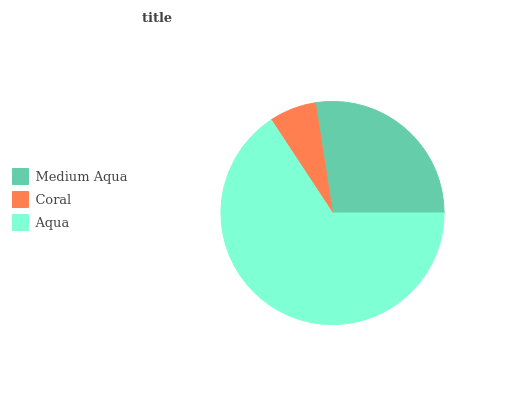Is Coral the minimum?
Answer yes or no. Yes. Is Aqua the maximum?
Answer yes or no. Yes. Is Aqua the minimum?
Answer yes or no. No. Is Coral the maximum?
Answer yes or no. No. Is Aqua greater than Coral?
Answer yes or no. Yes. Is Coral less than Aqua?
Answer yes or no. Yes. Is Coral greater than Aqua?
Answer yes or no. No. Is Aqua less than Coral?
Answer yes or no. No. Is Medium Aqua the high median?
Answer yes or no. Yes. Is Medium Aqua the low median?
Answer yes or no. Yes. Is Aqua the high median?
Answer yes or no. No. Is Coral the low median?
Answer yes or no. No. 